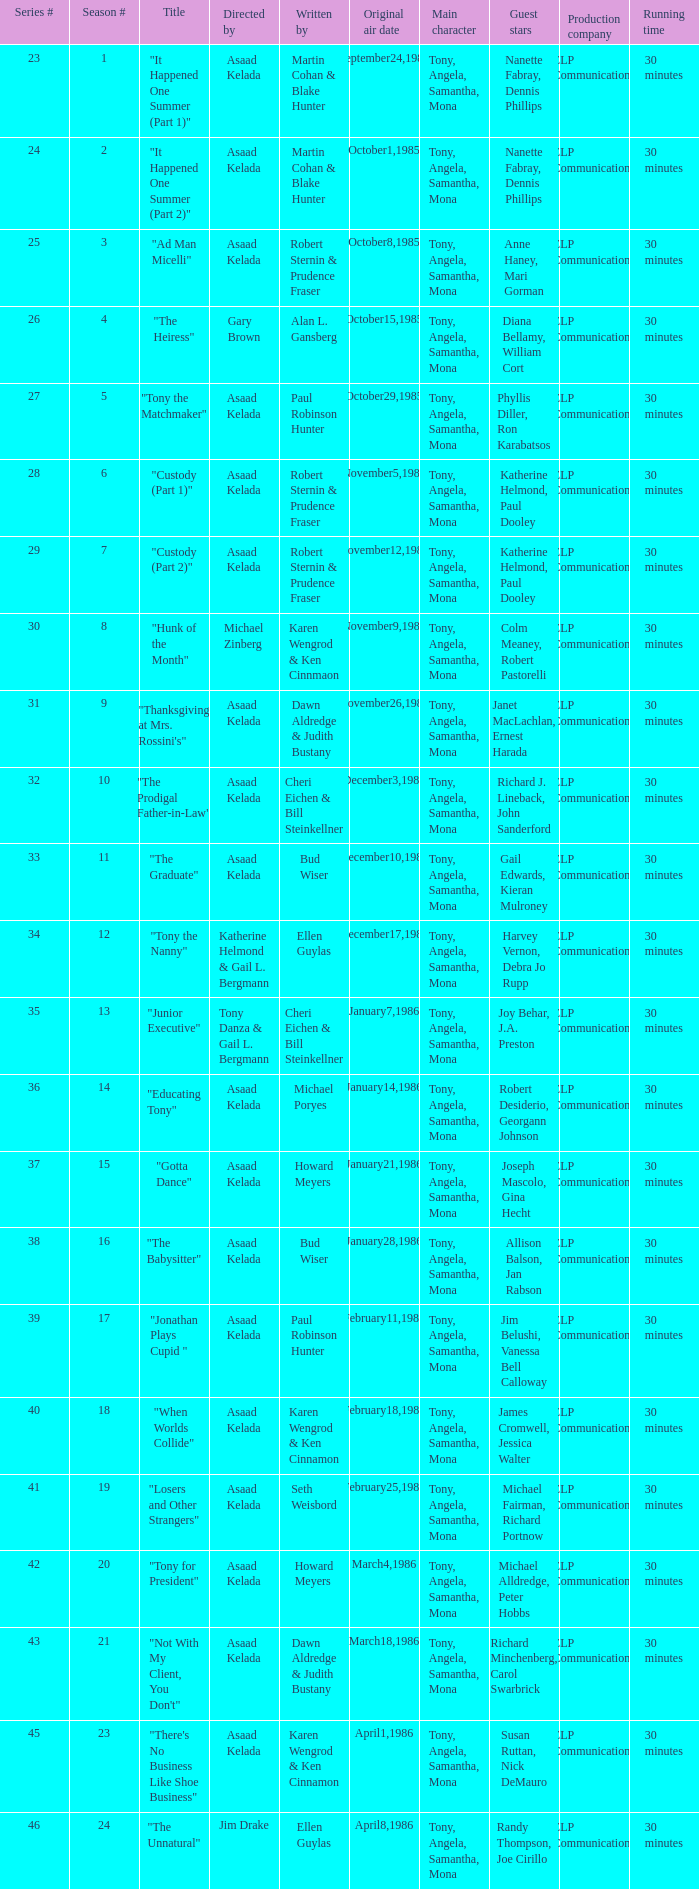Who were the authors of series episode #25? Robert Sternin & Prudence Fraser. 